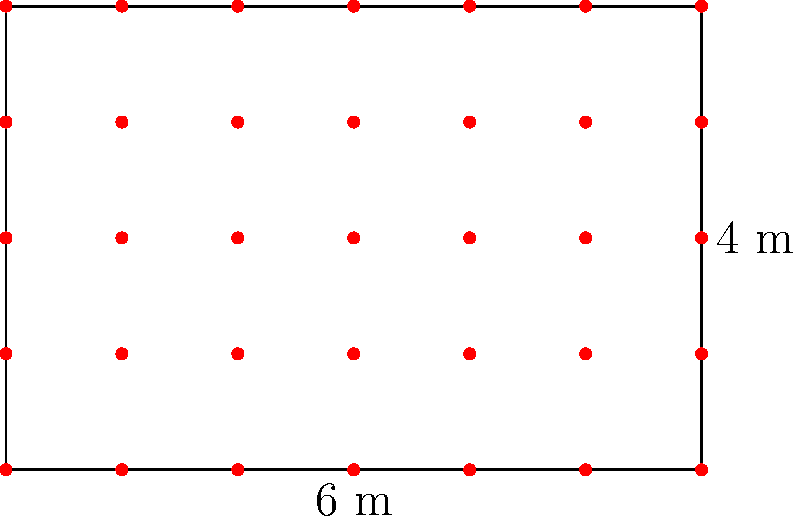You have a rectangular plot measuring 6 meters by 4 meters, as shown in the diagram. If seedlings are to be planted at each grid point (represented by red dots), how many seedlings will you need in total? To solve this problem, we need to follow these steps:

1) First, let's count the number of grid points along each side:
   - Along the 6-meter side, there are 7 points (including both ends)
   - Along the 4-meter side, there are 5 points (including both ends)

2) The total number of seedlings needed is equal to the total number of grid points, which can be calculated by multiplying the number of points on each side:

   $$ \text{Total seedlings} = 7 \times 5 $$

3) Let's perform this multiplication:

   $$ 7 \times 5 = 35 $$

Therefore, you will need 35 seedlings to plant at each grid point in the rectangular plot.
Answer: 35 seedlings 